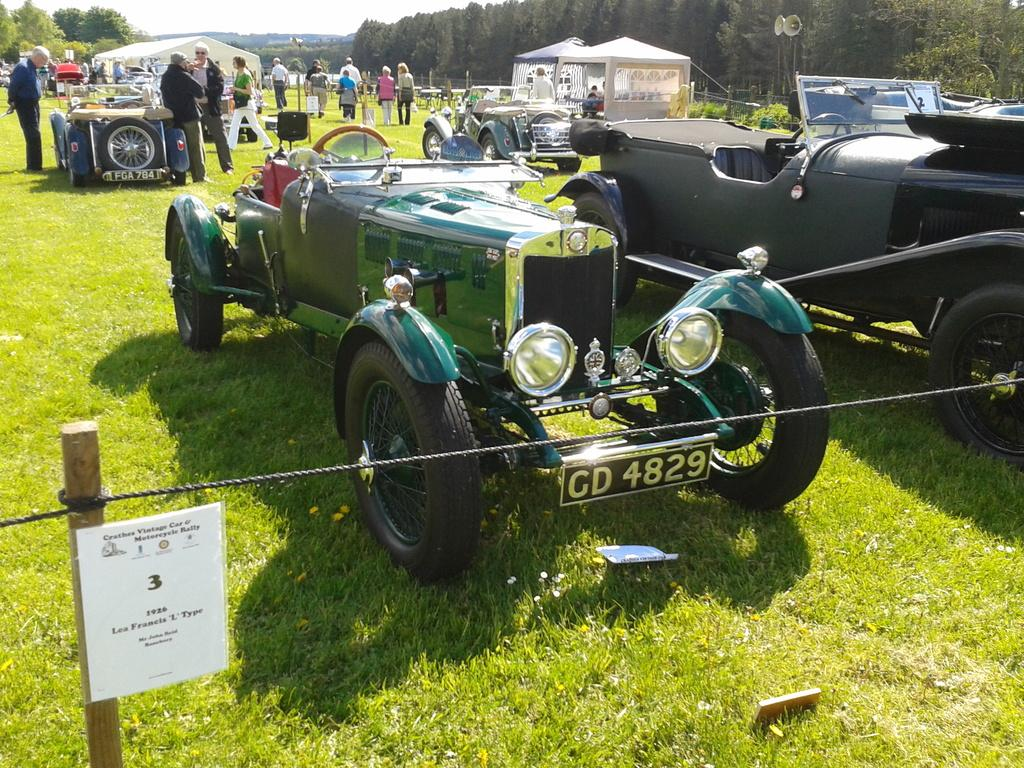What is the unusual location for the parked vehicles in the image? The vehicles are parked on the grass in the image. How many people can be seen in the image? There are many people in the image. What type of structures are visible in the image? There are houses in the image. What type of vegetation is present in the image? There are trees in the image. What might be used for amplifying sound in the image? There are speakers in the image. What is the purpose of the rope attached to the pole in the image? The purpose of the rope attached to the pole in the image is not clear from the facts provided. How many tomatoes are hanging from the rope attached to the pole in the image? There are no tomatoes present in the image; only a rope attached to a pole is mentioned. What type of lipstick is being used by the people in the image? There is no mention of lipstick or any cosmetic products in the image. 